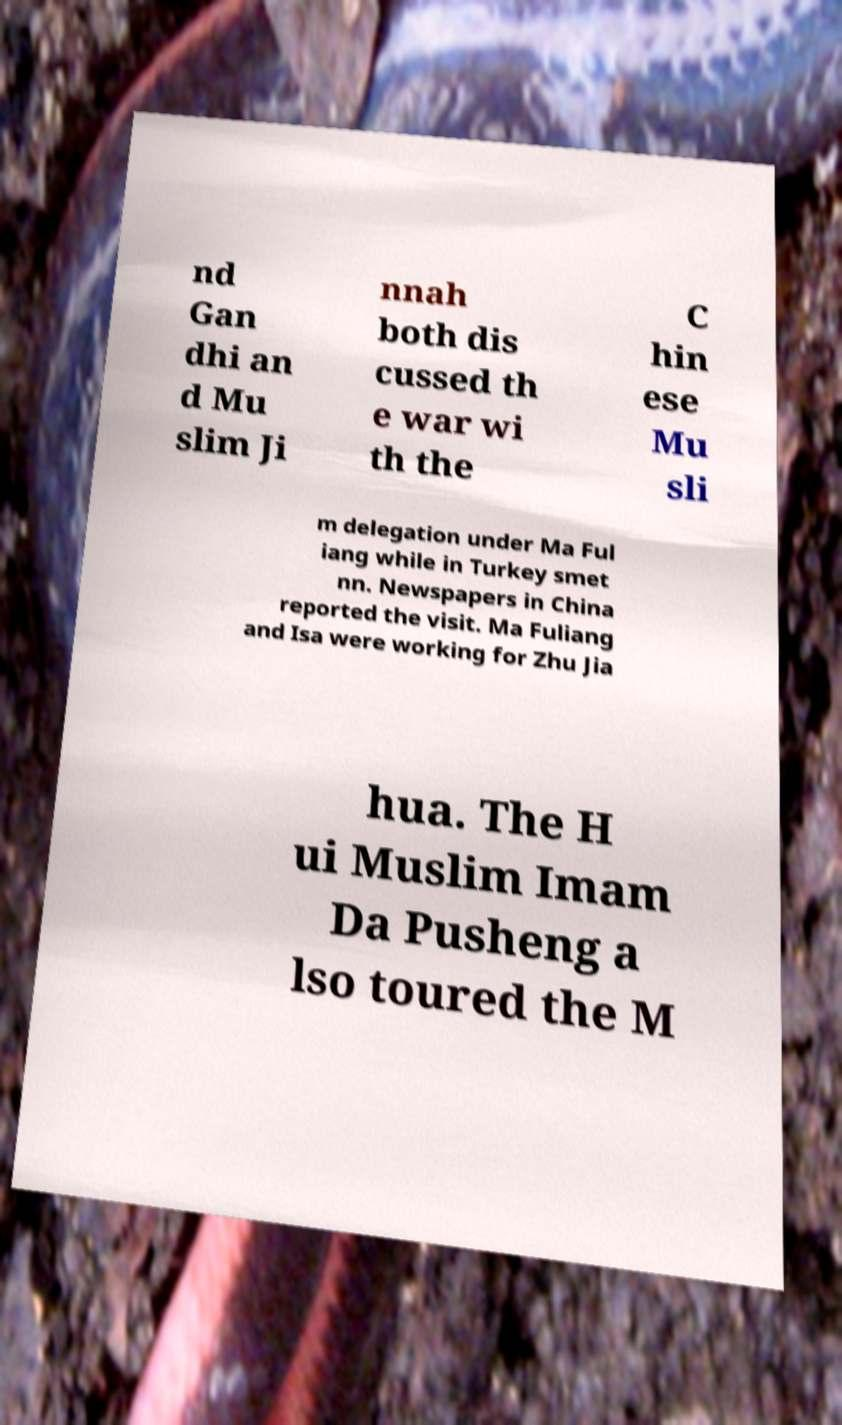Could you assist in decoding the text presented in this image and type it out clearly? nd Gan dhi an d Mu slim Ji nnah both dis cussed th e war wi th the C hin ese Mu sli m delegation under Ma Ful iang while in Turkey smet nn. Newspapers in China reported the visit. Ma Fuliang and Isa were working for Zhu Jia hua. The H ui Muslim Imam Da Pusheng a lso toured the M 